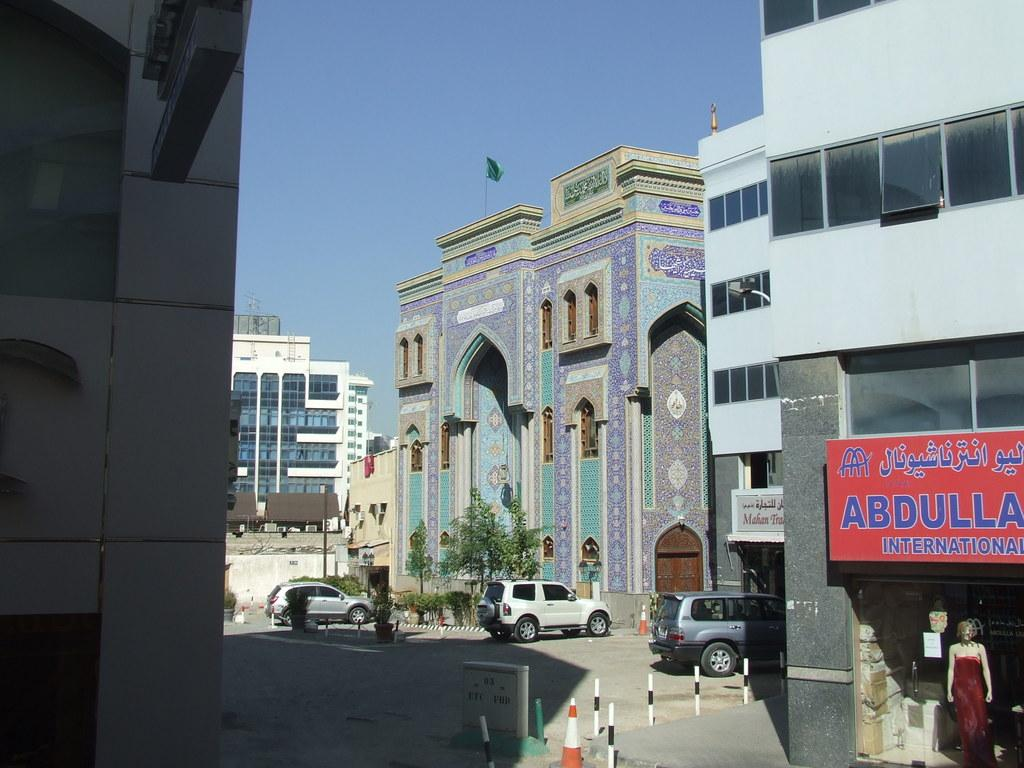What type of structures can be seen in the image? There are buildings in the image. What else can be seen on the ground in the image? There are vehicles on the road in the image. What objects are present in the image that resemble long, thin bars? There are rods in the image. What type of vegetation is visible in the image? There are trees in the image. What is attached to a building in the image? There is a flag on a building in the image. What type of human-like figure can be seen in the image? There is a mannequin in the image. What type of objects in the image have text written on them? There are boards with text in the image. What can be seen in the background of the image? The sky is visible in the background of the image. How many ducks are sitting on the mannequin in the image? There are no ducks present in the image, and the mannequin is not associated with any ducks. What type of shoe can be seen on the rods in the image? There are no shoes present on the rods in the image; they are simply long, thin bars. 